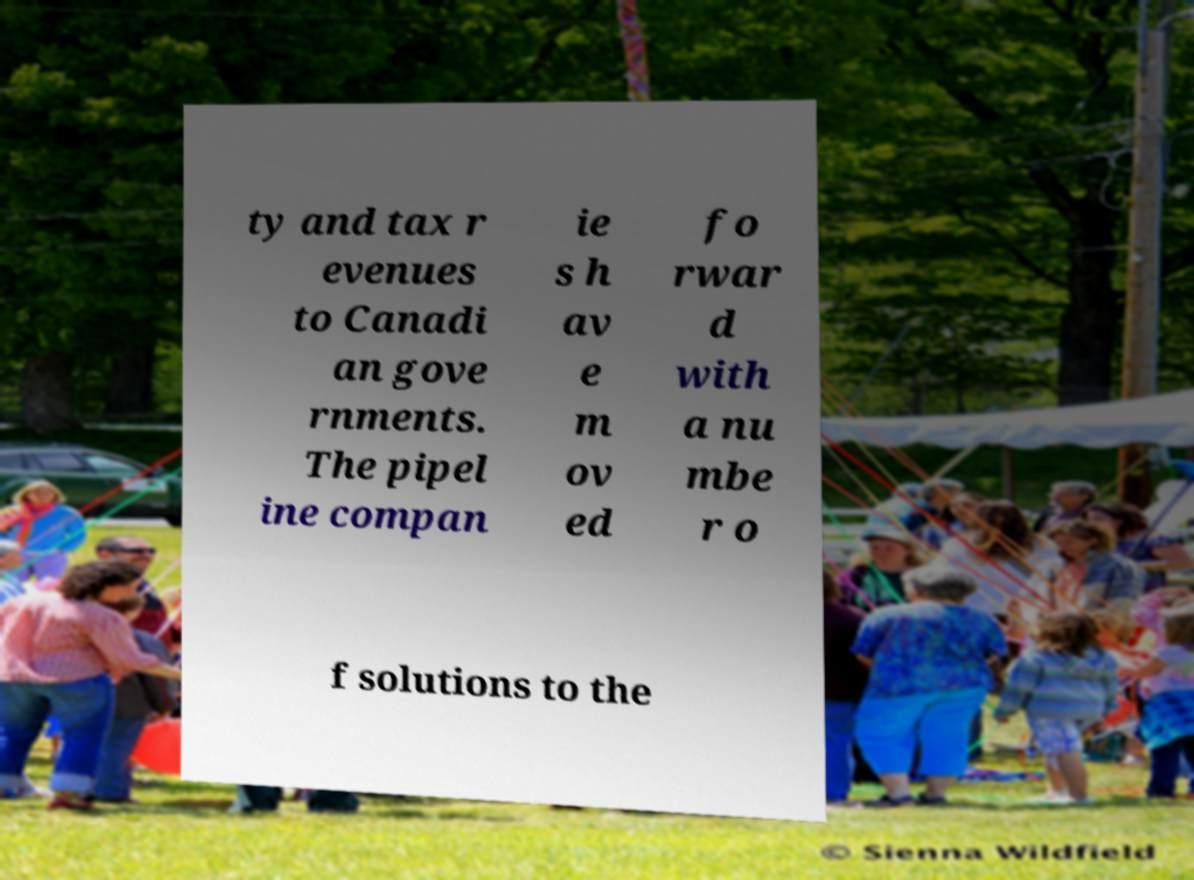What messages or text are displayed in this image? I need them in a readable, typed format. ty and tax r evenues to Canadi an gove rnments. The pipel ine compan ie s h av e m ov ed fo rwar d with a nu mbe r o f solutions to the 